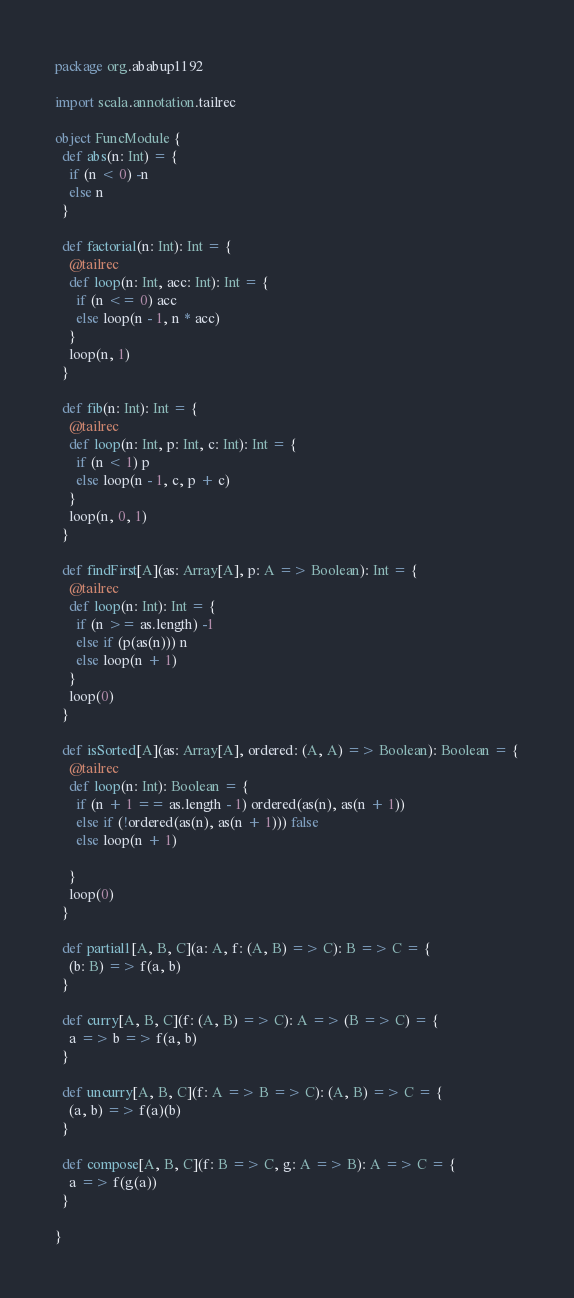Convert code to text. <code><loc_0><loc_0><loc_500><loc_500><_Scala_>package org.ababup1192

import scala.annotation.tailrec

object FuncModule {
  def abs(n: Int) = {
    if (n < 0) -n
    else n
  }

  def factorial(n: Int): Int = {
    @tailrec
    def loop(n: Int, acc: Int): Int = {
      if (n <= 0) acc
      else loop(n - 1, n * acc)
    }
    loop(n, 1)
  }

  def fib(n: Int): Int = {
    @tailrec
    def loop(n: Int, p: Int, c: Int): Int = {
      if (n < 1) p
      else loop(n - 1, c, p + c)
    }
    loop(n, 0, 1)
  }

  def findFirst[A](as: Array[A], p: A => Boolean): Int = {
    @tailrec
    def loop(n: Int): Int = {
      if (n >= as.length) -1
      else if (p(as(n))) n
      else loop(n + 1)
    }
    loop(0)
  }

  def isSorted[A](as: Array[A], ordered: (A, A) => Boolean): Boolean = {
    @tailrec
    def loop(n: Int): Boolean = {
      if (n + 1 == as.length - 1) ordered(as(n), as(n + 1))
      else if (!ordered(as(n), as(n + 1))) false
      else loop(n + 1)

    }
    loop(0)
  }

  def partial1[A, B, C](a: A, f: (A, B) => C): B => C = {
    (b: B) => f(a, b)
  }

  def curry[A, B, C](f: (A, B) => C): A => (B => C) = {
    a => b => f(a, b)
  }

  def uncurry[A, B, C](f: A => B => C): (A, B) => C = {
    (a, b) => f(a)(b)
  }

  def compose[A, B, C](f: B => C, g: A => B): A => C = {
    a => f(g(a))
  }

}
</code> 